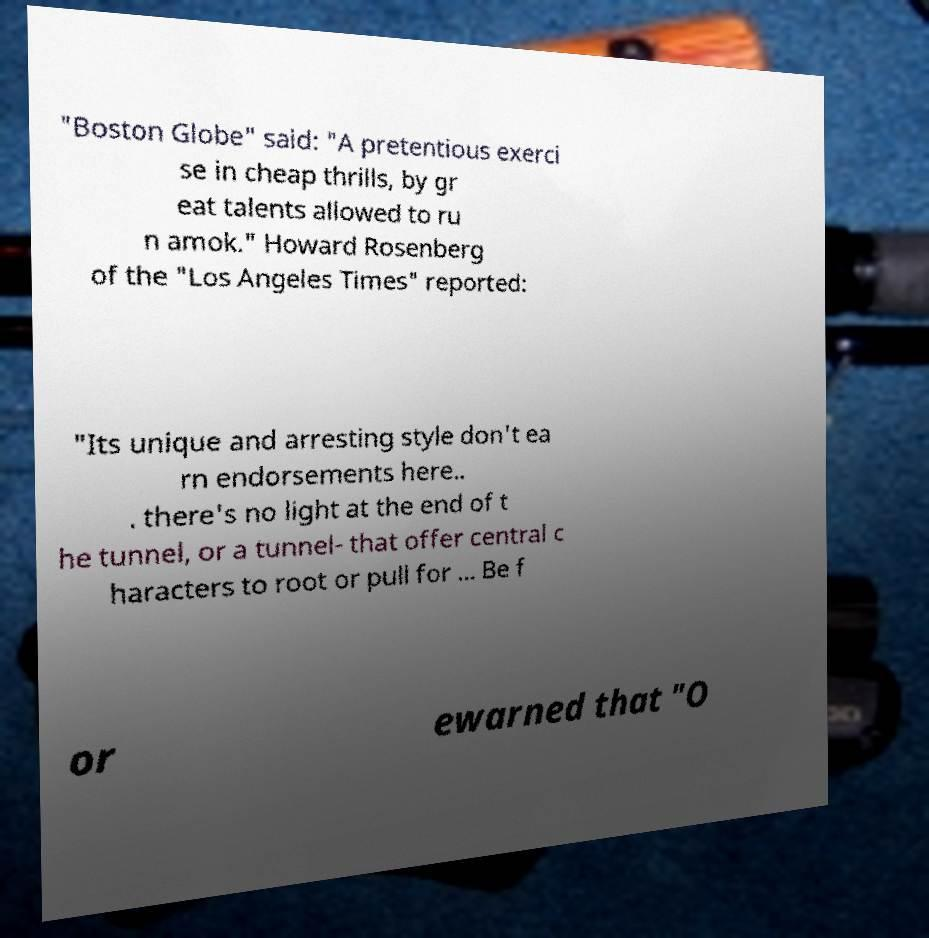Could you assist in decoding the text presented in this image and type it out clearly? "Boston Globe" said: "A pretentious exerci se in cheap thrills, by gr eat talents allowed to ru n amok." Howard Rosenberg of the "Los Angeles Times" reported: "Its unique and arresting style don't ea rn endorsements here.. . there's no light at the end of t he tunnel, or a tunnel- that offer central c haracters to root or pull for ... Be f or ewarned that "O 